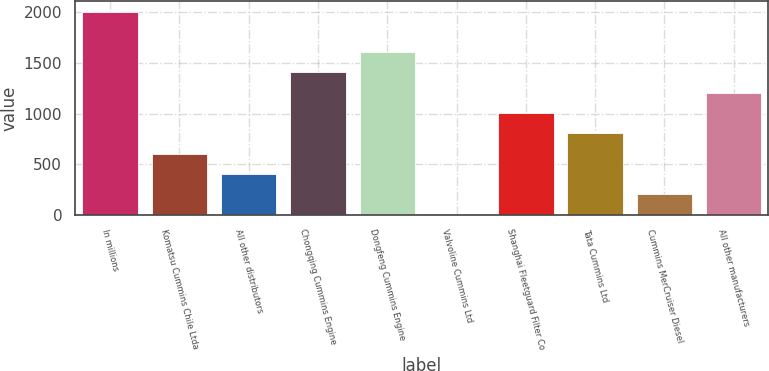Convert chart. <chart><loc_0><loc_0><loc_500><loc_500><bar_chart><fcel>In millions<fcel>Komatsu Cummins Chile Ltda<fcel>All other distributors<fcel>Chongqing Cummins Engine<fcel>Dongfeng Cummins Engine<fcel>Valvoline Cummins Ltd<fcel>Shanghai Fleetguard Filter Co<fcel>Tata Cummins Ltd<fcel>Cummins MerCruiser Diesel<fcel>All other manufacturers<nl><fcel>2008<fcel>603.1<fcel>402.4<fcel>1405.9<fcel>1606.6<fcel>1<fcel>1004.5<fcel>803.8<fcel>201.7<fcel>1205.2<nl></chart> 